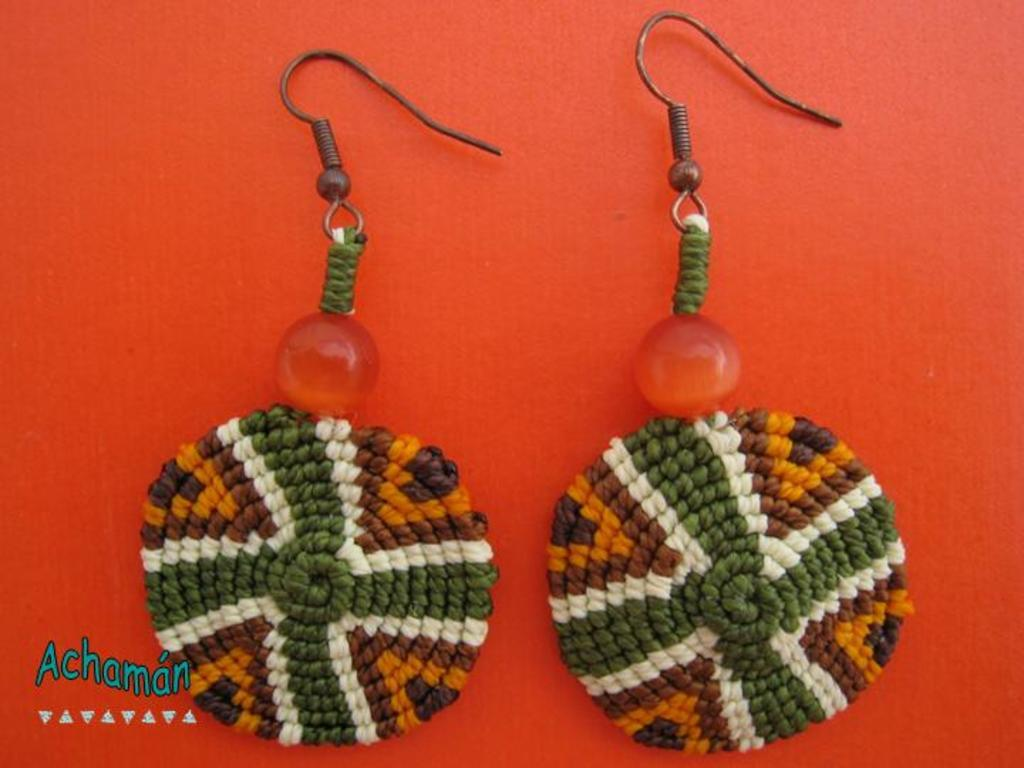What type of accessory is featured in the image? There are earrings in the image. What is the earrings placed on? The earrings are on a red color platform. Where can text be found in the image? There is text on the left side of the image. What type of metal is the governor using to build the school in the image? There is no governor, metal, or school present in the image. 